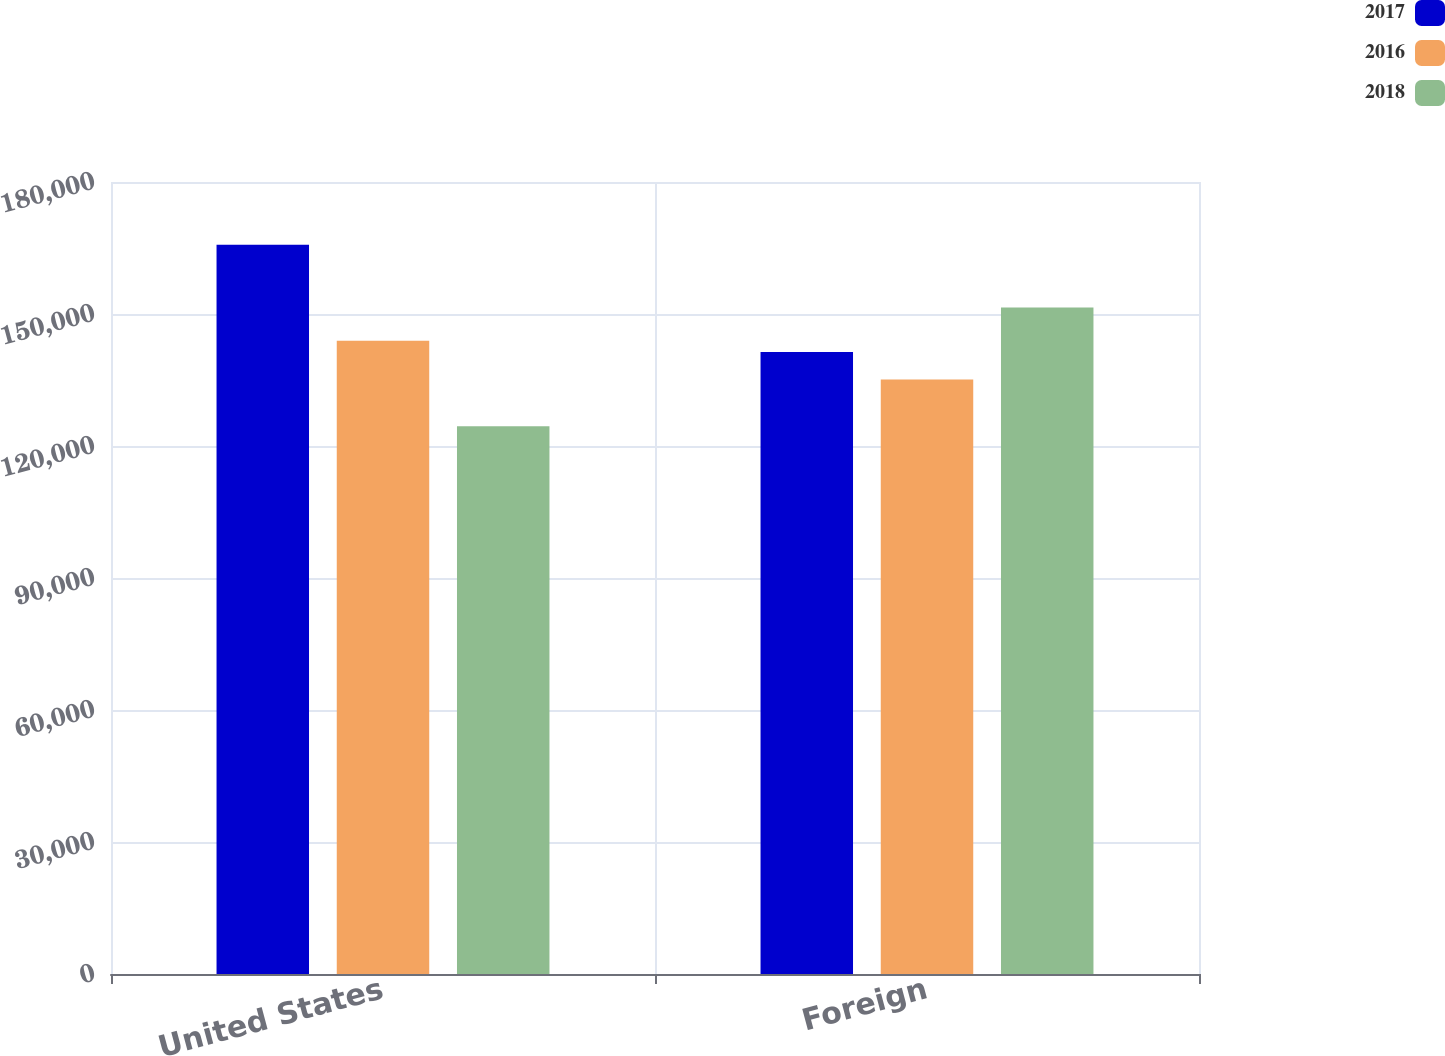Convert chart to OTSL. <chart><loc_0><loc_0><loc_500><loc_500><stacked_bar_chart><ecel><fcel>United States<fcel>Foreign<nl><fcel>2017<fcel>165719<fcel>141384<nl><fcel>2016<fcel>143924<fcel>135141<nl><fcel>2018<fcel>124500<fcel>151457<nl></chart> 